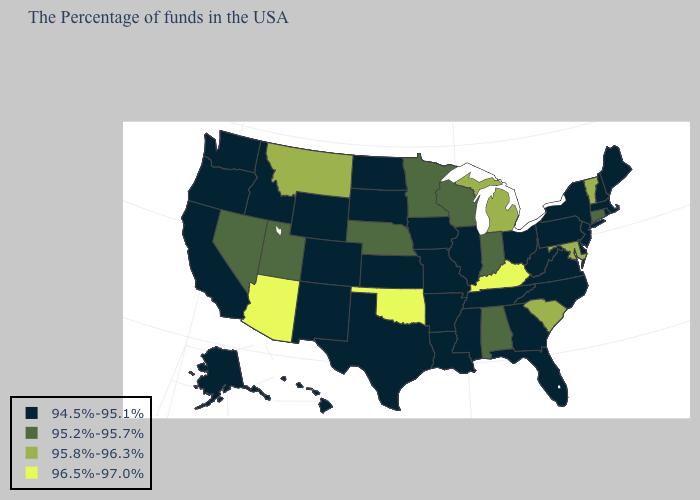How many symbols are there in the legend?
Give a very brief answer. 4. Among the states that border Rhode Island , which have the lowest value?
Answer briefly. Massachusetts. Among the states that border Oklahoma , which have the lowest value?
Write a very short answer. Missouri, Arkansas, Kansas, Texas, Colorado, New Mexico. What is the value of New Mexico?
Concise answer only. 94.5%-95.1%. Does the map have missing data?
Quick response, please. No. Does the map have missing data?
Answer briefly. No. What is the highest value in the USA?
Quick response, please. 96.5%-97.0%. Which states have the highest value in the USA?
Keep it brief. Kentucky, Oklahoma, Arizona. Does Indiana have the lowest value in the USA?
Be succinct. No. Among the states that border Florida , which have the lowest value?
Quick response, please. Georgia. What is the value of Iowa?
Quick response, please. 94.5%-95.1%. What is the highest value in the Northeast ?
Answer briefly. 95.8%-96.3%. What is the value of California?
Short answer required. 94.5%-95.1%. Which states hav the highest value in the South?
Short answer required. Kentucky, Oklahoma. What is the value of Pennsylvania?
Short answer required. 94.5%-95.1%. 